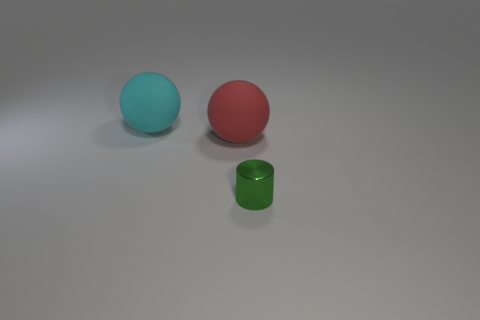What number of blocks are either large cyan things or metallic objects?
Ensure brevity in your answer.  0. What shape is the object that is both left of the small thing and in front of the cyan matte thing?
Keep it short and to the point. Sphere. Are there any other things of the same size as the green shiny object?
Your response must be concise. No. What number of objects are balls that are in front of the cyan sphere or big matte balls?
Provide a succinct answer. 2. Is the small cylinder made of the same material as the sphere on the left side of the red rubber sphere?
Give a very brief answer. No. How many other things are the same shape as the big cyan object?
Your response must be concise. 1. What number of things are things that are behind the tiny green cylinder or objects that are on the right side of the cyan matte thing?
Your answer should be very brief. 3. How many other objects are there of the same color as the metal object?
Keep it short and to the point. 0. Are there fewer cyan things that are in front of the large red sphere than small green things that are in front of the large cyan object?
Ensure brevity in your answer.  Yes. How many cylinders are there?
Offer a very short reply. 1. 